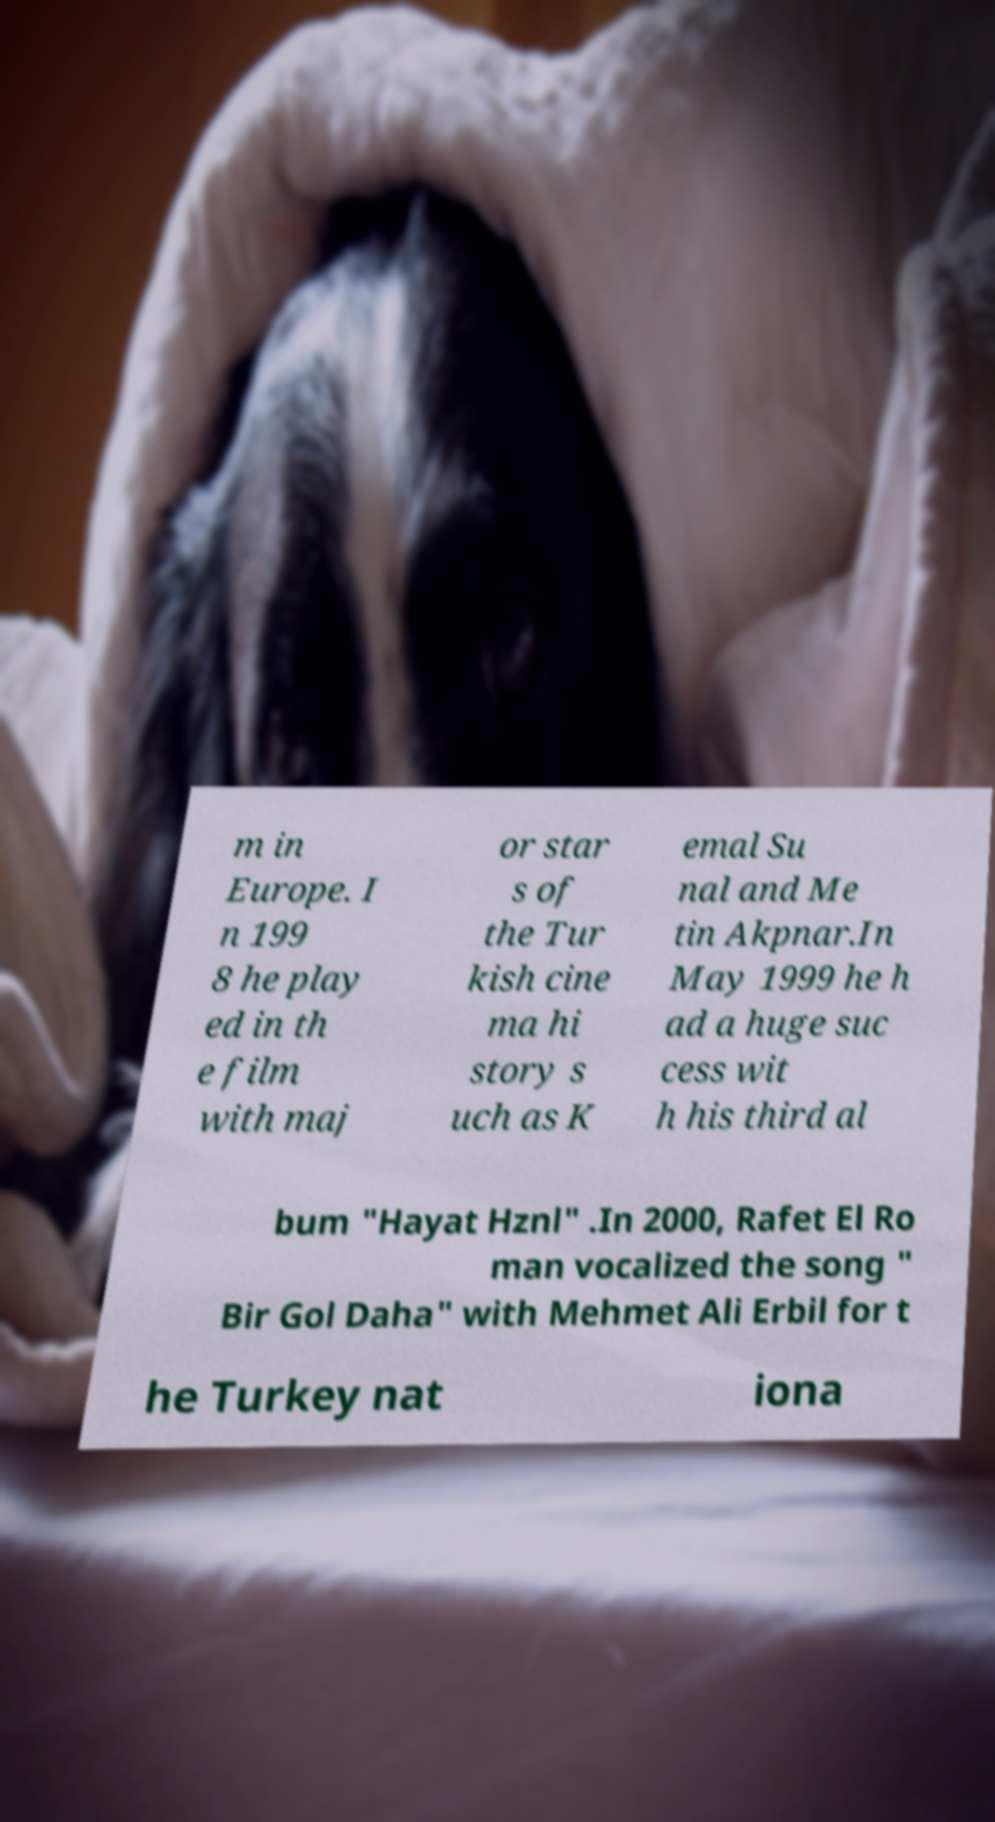What messages or text are displayed in this image? I need them in a readable, typed format. m in Europe. I n 199 8 he play ed in th e film with maj or star s of the Tur kish cine ma hi story s uch as K emal Su nal and Me tin Akpnar.In May 1999 he h ad a huge suc cess wit h his third al bum "Hayat Hznl" .In 2000, Rafet El Ro man vocalized the song " Bir Gol Daha" with Mehmet Ali Erbil for t he Turkey nat iona 